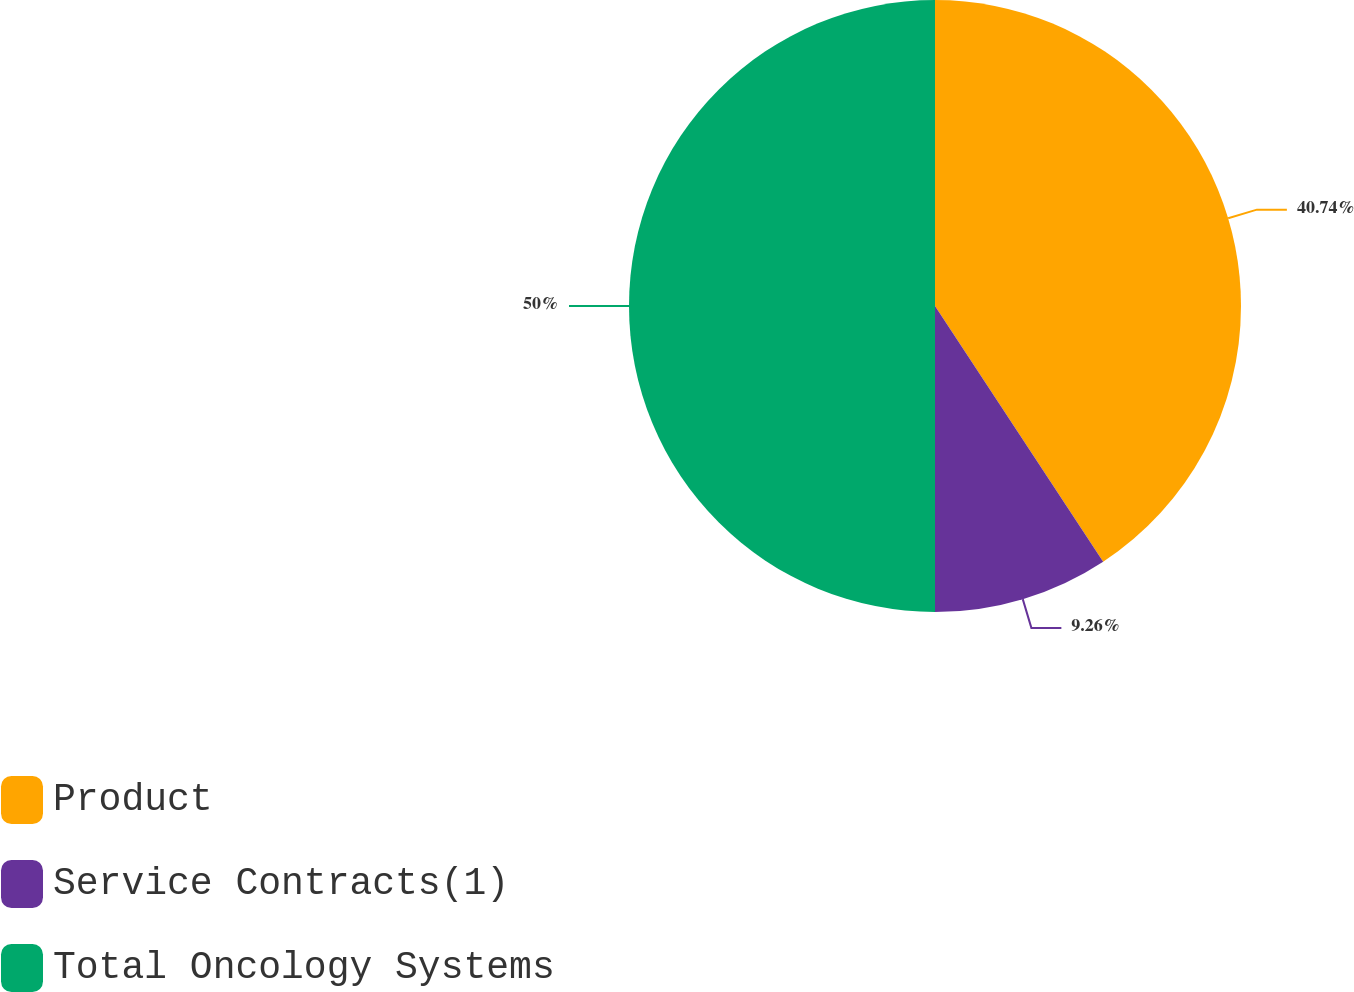<chart> <loc_0><loc_0><loc_500><loc_500><pie_chart><fcel>Product<fcel>Service Contracts(1)<fcel>Total Oncology Systems<nl><fcel>40.74%<fcel>9.26%<fcel>50.0%<nl></chart> 